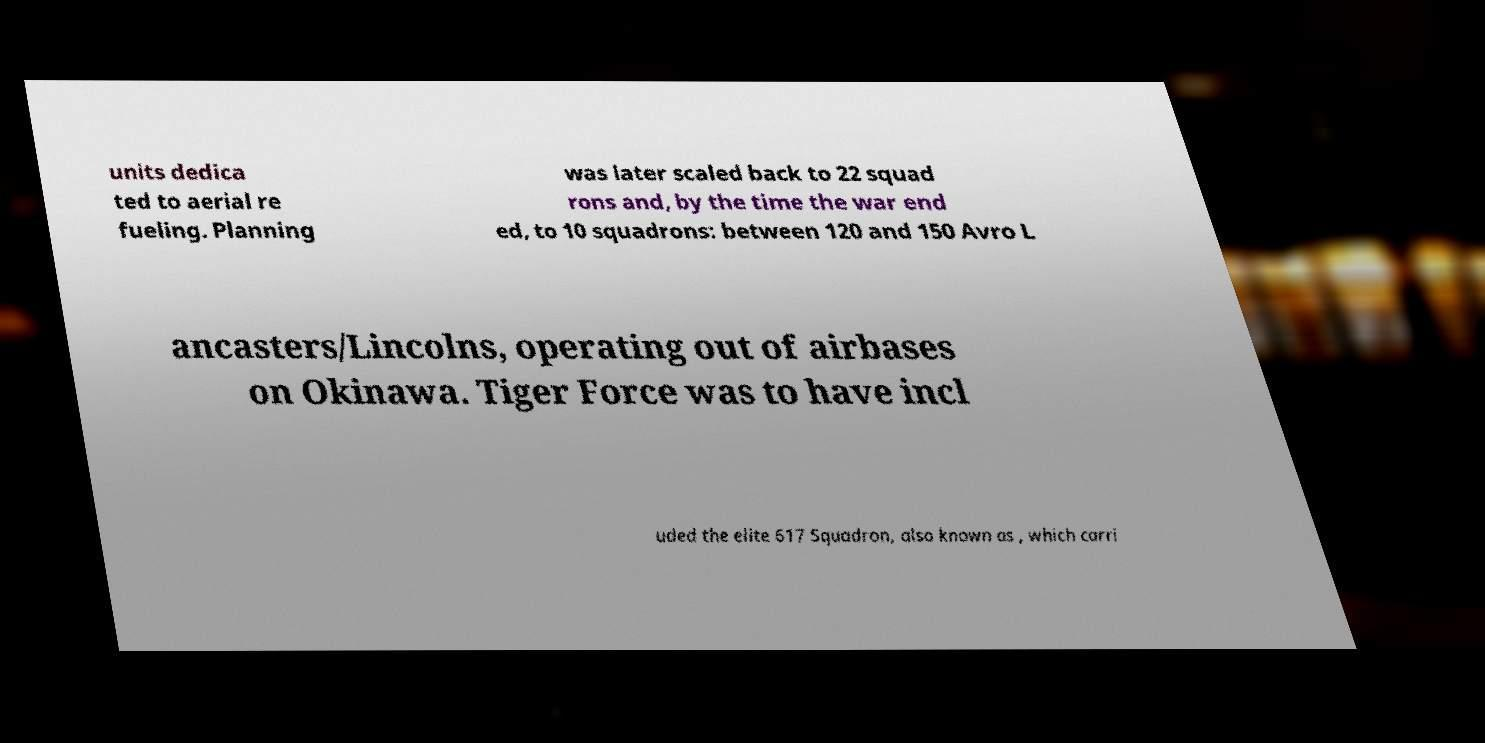What messages or text are displayed in this image? I need them in a readable, typed format. units dedica ted to aerial re fueling. Planning was later scaled back to 22 squad rons and, by the time the war end ed, to 10 squadrons: between 120 and 150 Avro L ancasters/Lincolns, operating out of airbases on Okinawa. Tiger Force was to have incl uded the elite 617 Squadron, also known as , which carri 